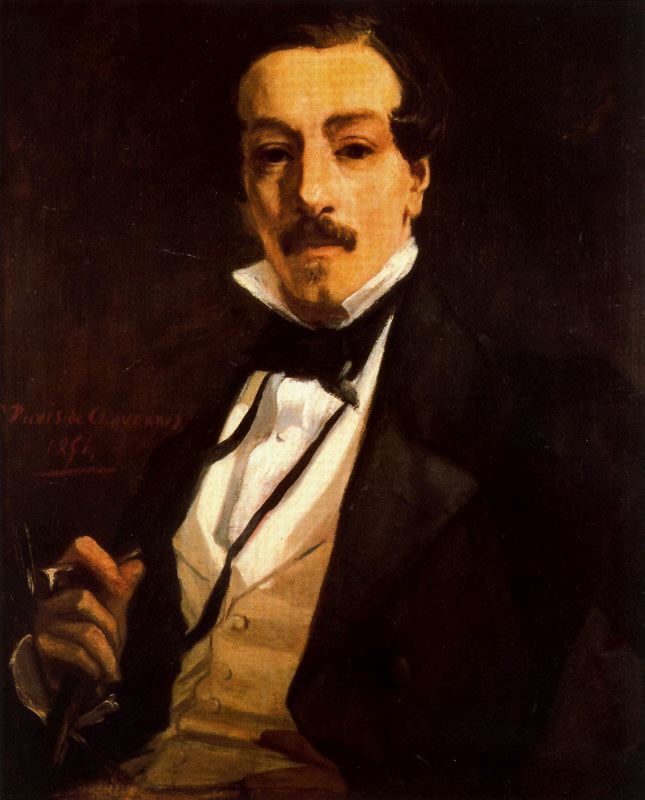Can you describe the background details in the painting? The background of the painting is composed of dark and muted tones, predominantly deep browns and blacks. These colors serve to enhance the formal and serious atmosphere of the portrait. The lack of intricate details in the backdrop ensures that the viewer's focus remains on the subject. The smooth, almost shadowy effect of the background contrasts with the lighter tones of the man's clothing and skin, adding depth and a touch of mystery to the overall composition. 